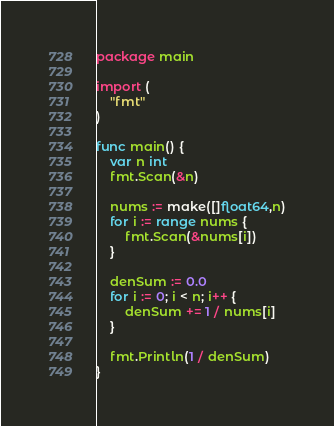Convert code to text. <code><loc_0><loc_0><loc_500><loc_500><_Go_>package main

import (
	"fmt"
)

func main() {
	var n int
	fmt.Scan(&n)
	
	nums := make([]float64,n)
	for i := range nums {
		fmt.Scan(&nums[i])
	}
  
	denSum := 0.0
	for i := 0; i < n; i++ {
		denSum += 1 / nums[i]
	}
	
	fmt.Println(1 / denSum)
}</code> 